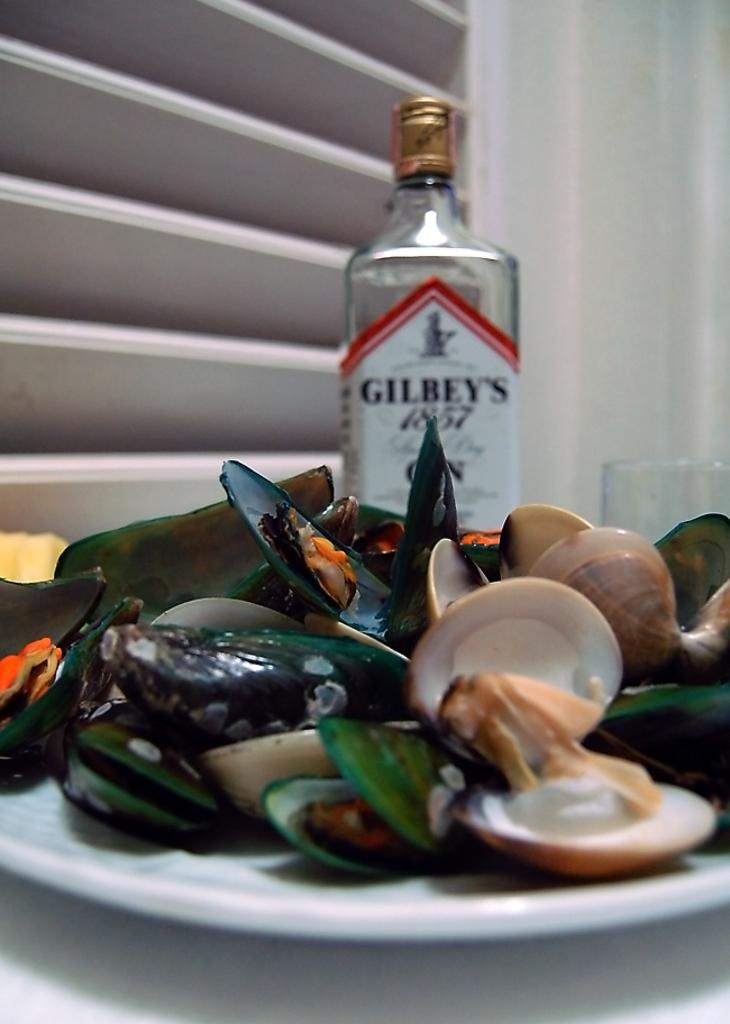Where was the image taken? The image was taken inside a room. What is on the table in the image? There are plates filled with oysters, one bottle, and one glass on the table. Can you describe the window in the image? There is a window behind the table. What is the fear level of the oysters in the image? There is no indication of fear in the image, as oysters do not have emotions. 